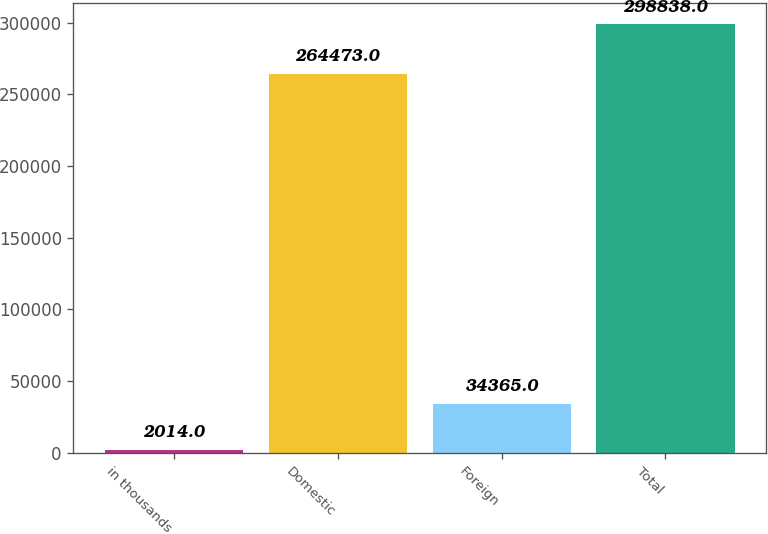Convert chart. <chart><loc_0><loc_0><loc_500><loc_500><bar_chart><fcel>in thousands<fcel>Domestic<fcel>Foreign<fcel>Total<nl><fcel>2014<fcel>264473<fcel>34365<fcel>298838<nl></chart> 